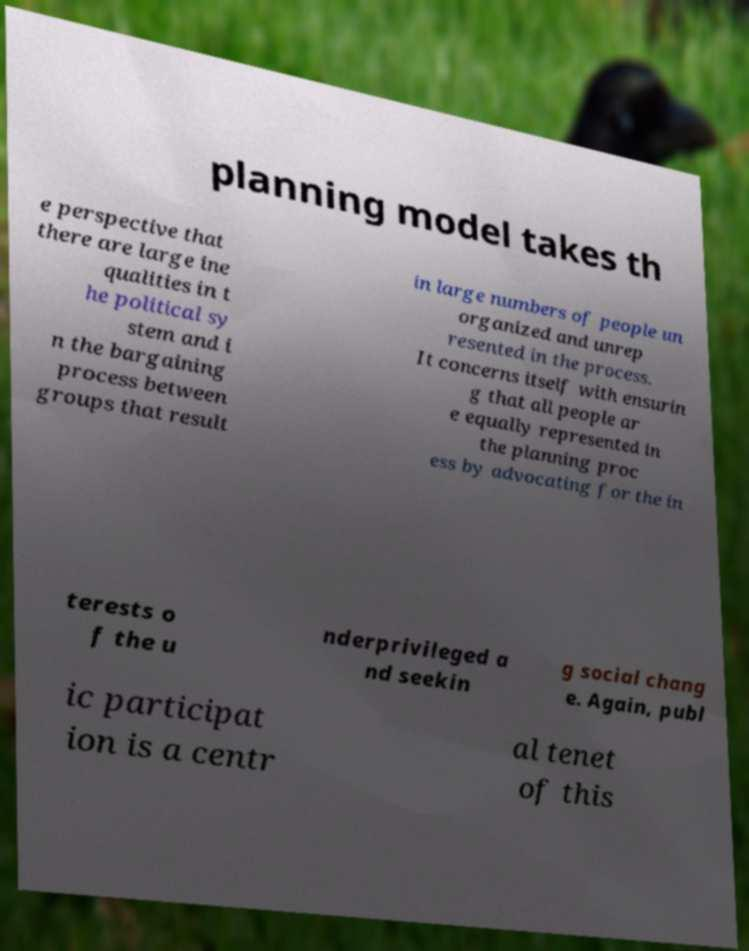Please identify and transcribe the text found in this image. planning model takes th e perspective that there are large ine qualities in t he political sy stem and i n the bargaining process between groups that result in large numbers of people un organized and unrep resented in the process. It concerns itself with ensurin g that all people ar e equally represented in the planning proc ess by advocating for the in terests o f the u nderprivileged a nd seekin g social chang e. Again, publ ic participat ion is a centr al tenet of this 